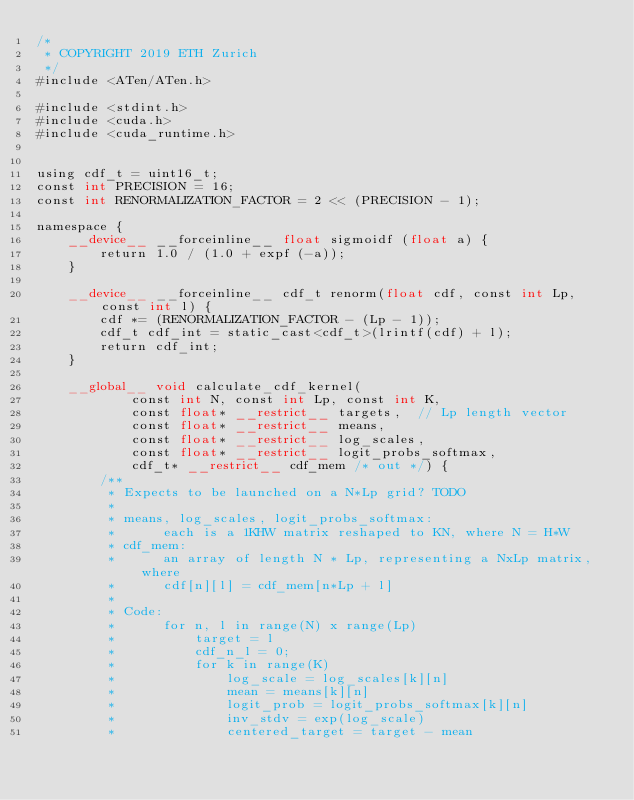Convert code to text. <code><loc_0><loc_0><loc_500><loc_500><_Cuda_>/*
 * COPYRIGHT 2019 ETH Zurich
 */
#include <ATen/ATen.h>

#include <stdint.h>
#include <cuda.h>
#include <cuda_runtime.h>


using cdf_t = uint16_t;
const int PRECISION = 16;
const int RENORMALIZATION_FACTOR = 2 << (PRECISION - 1);

namespace {
    __device__ __forceinline__ float sigmoidf (float a) {
        return 1.0 / (1.0 + expf (-a));
    }

    __device__ __forceinline__ cdf_t renorm(float cdf, const int Lp, const int l) {
        cdf *= (RENORMALIZATION_FACTOR - (Lp - 1));
        cdf_t cdf_int = static_cast<cdf_t>(lrintf(cdf) + l);
        return cdf_int;
    }

    __global__ void calculate_cdf_kernel(
            const int N, const int Lp, const int K,
            const float* __restrict__ targets,  // Lp length vector
            const float* __restrict__ means,
            const float* __restrict__ log_scales,
            const float* __restrict__ logit_probs_softmax,
            cdf_t* __restrict__ cdf_mem /* out */) {
        /**
         * Expects to be launched on a N*Lp grid? TODO
         *
         * means, log_scales, logit_probs_softmax:
         *      each is a 1KHW matrix reshaped to KN, where N = H*W
         * cdf_mem:
         *      an array of length N * Lp, representing a NxLp matrix, where
         *      cdf[n][l] = cdf_mem[n*Lp + l]
         *
         * Code:
         *      for n, l in range(N) x range(Lp)
         *          target = l
         *          cdf_n_l = 0;
         *          for k in range(K)
         *              log_scale = log_scales[k][n]
         *              mean = means[k][n]
         *              logit_prob = logit_probs_softmax[k][n]
         *              inv_stdv = exp(log_scale)
         *              centered_target = target - mean</code> 